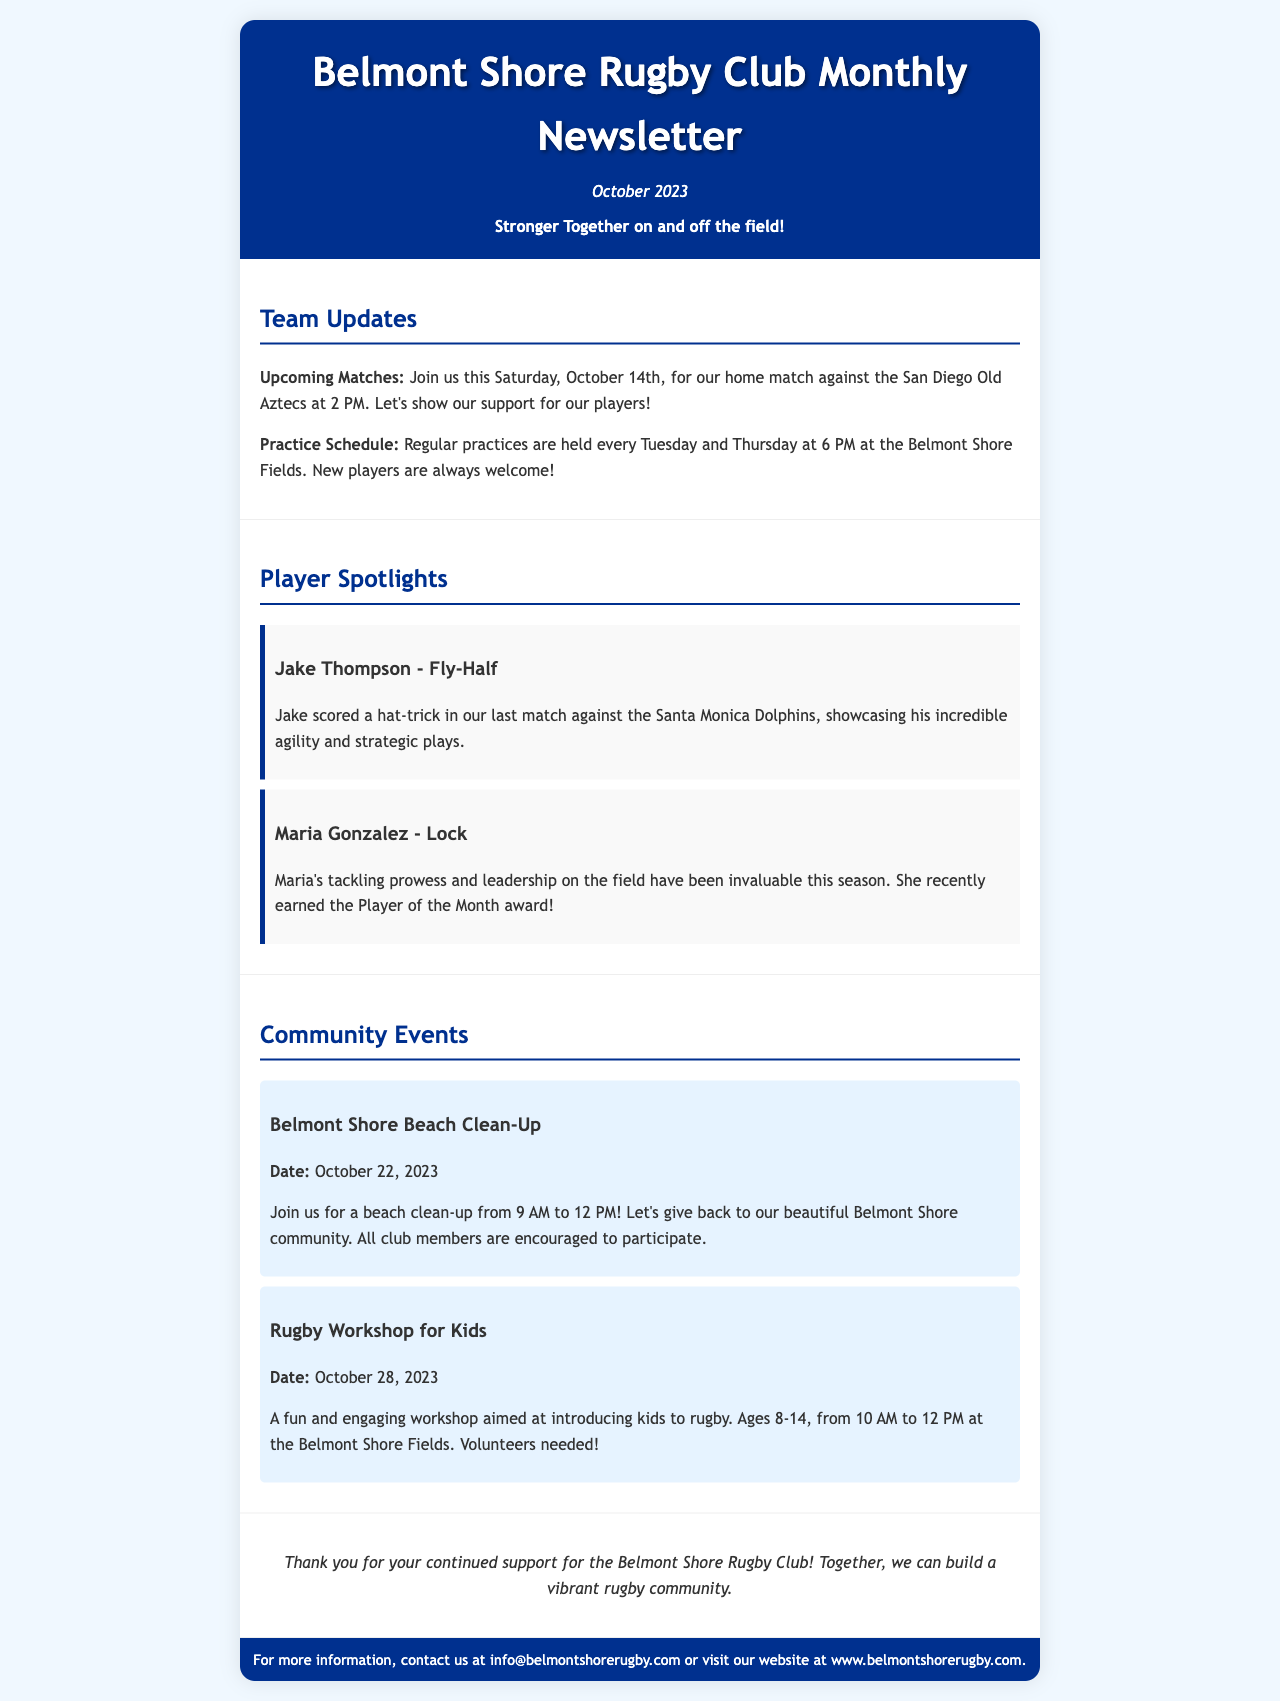what is the date of the upcoming match? The upcoming match is scheduled for Saturday, October 14th.
Answer: October 14th who is spotlighted as the Player of the Month? Maria Gonzalez is highlighted for earning the Player of the Month award.
Answer: Maria Gonzalez what time do regular practices start? Regular practices are held at 6 PM every Tuesday and Thursday.
Answer: 6 PM when is the Belmont Shore Beach Clean-Up event? The date for the beach clean-up event is mentioned in the document.
Answer: October 22, 2023 how many players are spotlighted in the newsletter? The newsletter highlights two players in the Player Spotlights section.
Answer: Two players what type of workshop is being offered for kids? The document states that a rugby workshop will be held for kids.
Answer: Rugby workshop what is the slogan of the Belmont Shore Rugby Club? The slogan of the club is displayed in the header of the newsletter.
Answer: Stronger Together on and off the field! who should members contact for more information? The contact information in the document suggests who to reach out to for inquiries.
Answer: info@belmontshorerugby.com what is the purpose of the rugby workshop for kids? The purpose of the workshop is detailed in the document, aimed at introducing kids to rugby.
Answer: Introducing kids to rugby 